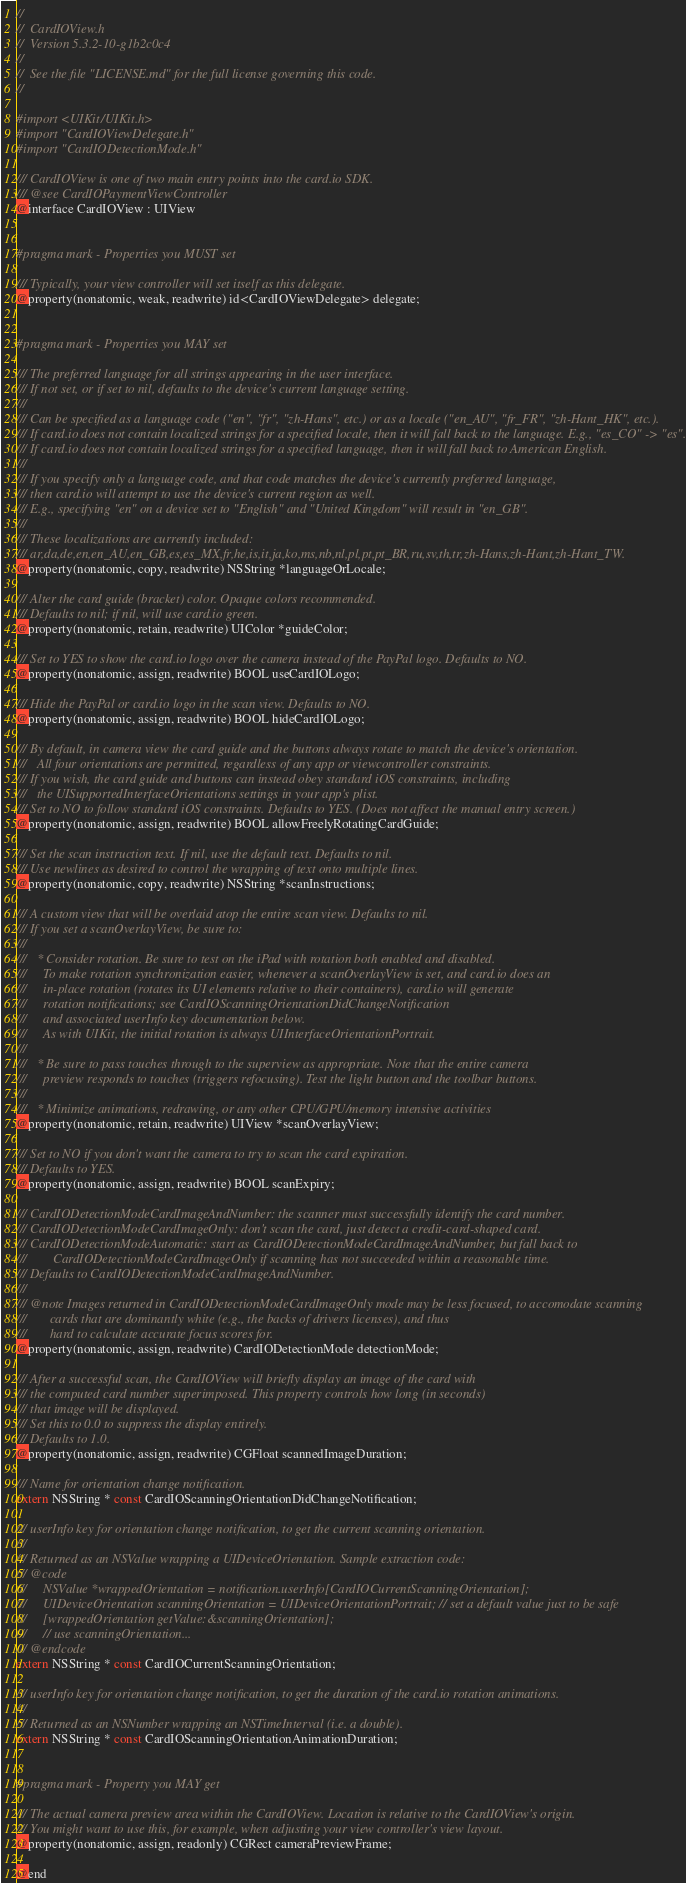<code> <loc_0><loc_0><loc_500><loc_500><_C_>//
//  CardIOView.h
//  Version 5.3.2-10-g1b2c0c4
//
//  See the file "LICENSE.md" for the full license governing this code.
//

#import <UIKit/UIKit.h>
#import "CardIOViewDelegate.h"
#import "CardIODetectionMode.h"

/// CardIOView is one of two main entry points into the card.io SDK.
/// @see CardIOPaymentViewController
@interface CardIOView : UIView


#pragma mark - Properties you MUST set

/// Typically, your view controller will set itself as this delegate.
@property(nonatomic, weak, readwrite) id<CardIOViewDelegate> delegate;


#pragma mark - Properties you MAY set

/// The preferred language for all strings appearing in the user interface.
/// If not set, or if set to nil, defaults to the device's current language setting.
///
/// Can be specified as a language code ("en", "fr", "zh-Hans", etc.) or as a locale ("en_AU", "fr_FR", "zh-Hant_HK", etc.).
/// If card.io does not contain localized strings for a specified locale, then it will fall back to the language. E.g., "es_CO" -> "es".
/// If card.io does not contain localized strings for a specified language, then it will fall back to American English.
///
/// If you specify only a language code, and that code matches the device's currently preferred language,
/// then card.io will attempt to use the device's current region as well.
/// E.g., specifying "en" on a device set to "English" and "United Kingdom" will result in "en_GB".
///
/// These localizations are currently included:
/// ar,da,de,en,en_AU,en_GB,es,es_MX,fr,he,is,it,ja,ko,ms,nb,nl,pl,pt,pt_BR,ru,sv,th,tr,zh-Hans,zh-Hant,zh-Hant_TW.
@property(nonatomic, copy, readwrite) NSString *languageOrLocale;

/// Alter the card guide (bracket) color. Opaque colors recommended.
/// Defaults to nil; if nil, will use card.io green.
@property(nonatomic, retain, readwrite) UIColor *guideColor;

/// Set to YES to show the card.io logo over the camera instead of the PayPal logo. Defaults to NO.
@property(nonatomic, assign, readwrite) BOOL useCardIOLogo;

/// Hide the PayPal or card.io logo in the scan view. Defaults to NO.
@property(nonatomic, assign, readwrite) BOOL hideCardIOLogo;

/// By default, in camera view the card guide and the buttons always rotate to match the device's orientation.
///   All four orientations are permitted, regardless of any app or viewcontroller constraints.
/// If you wish, the card guide and buttons can instead obey standard iOS constraints, including
///   the UISupportedInterfaceOrientations settings in your app's plist.
/// Set to NO to follow standard iOS constraints. Defaults to YES. (Does not affect the manual entry screen.)
@property(nonatomic, assign, readwrite) BOOL allowFreelyRotatingCardGuide;

/// Set the scan instruction text. If nil, use the default text. Defaults to nil.
/// Use newlines as desired to control the wrapping of text onto multiple lines.
@property(nonatomic, copy, readwrite) NSString *scanInstructions;

/// A custom view that will be overlaid atop the entire scan view. Defaults to nil.
/// If you set a scanOverlayView, be sure to:
///
///   * Consider rotation. Be sure to test on the iPad with rotation both enabled and disabled.
///     To make rotation synchronization easier, whenever a scanOverlayView is set, and card.io does an
///     in-place rotation (rotates its UI elements relative to their containers), card.io will generate
///     rotation notifications; see CardIOScanningOrientationDidChangeNotification
///     and associated userInfo key documentation below.
///     As with UIKit, the initial rotation is always UIInterfaceOrientationPortrait.
///
///   * Be sure to pass touches through to the superview as appropriate. Note that the entire camera
///     preview responds to touches (triggers refocusing). Test the light button and the toolbar buttons.
///
///   * Minimize animations, redrawing, or any other CPU/GPU/memory intensive activities
@property(nonatomic, retain, readwrite) UIView *scanOverlayView;

/// Set to NO if you don't want the camera to try to scan the card expiration.
/// Defaults to YES.
@property(nonatomic, assign, readwrite) BOOL scanExpiry;

/// CardIODetectionModeCardImageAndNumber: the scanner must successfully identify the card number.
/// CardIODetectionModeCardImageOnly: don't scan the card, just detect a credit-card-shaped card.
/// CardIODetectionModeAutomatic: start as CardIODetectionModeCardImageAndNumber, but fall back to
///        CardIODetectionModeCardImageOnly if scanning has not succeeded within a reasonable time.
/// Defaults to CardIODetectionModeCardImageAndNumber.
///
/// @note Images returned in CardIODetectionModeCardImageOnly mode may be less focused, to accomodate scanning
///       cards that are dominantly white (e.g., the backs of drivers licenses), and thus
///       hard to calculate accurate focus scores for.
@property(nonatomic, assign, readwrite) CardIODetectionMode detectionMode;

/// After a successful scan, the CardIOView will briefly display an image of the card with
/// the computed card number superimposed. This property controls how long (in seconds)
/// that image will be displayed.
/// Set this to 0.0 to suppress the display entirely.
/// Defaults to 1.0.
@property(nonatomic, assign, readwrite) CGFloat scannedImageDuration;

/// Name for orientation change notification.
extern NSString * const CardIOScanningOrientationDidChangeNotification;

/// userInfo key for orientation change notification, to get the current scanning orientation.
///
/// Returned as an NSValue wrapping a UIDeviceOrientation. Sample extraction code:
/// @code
///     NSValue *wrappedOrientation = notification.userInfo[CardIOCurrentScanningOrientation];
///     UIDeviceOrientation scanningOrientation = UIDeviceOrientationPortrait; // set a default value just to be safe
///     [wrappedOrientation getValue:&scanningOrientation];
///     // use scanningOrientation...
/// @endcode
extern NSString * const CardIOCurrentScanningOrientation;

/// userInfo key for orientation change notification, to get the duration of the card.io rotation animations.
///
/// Returned as an NSNumber wrapping an NSTimeInterval (i.e. a double).
extern NSString * const CardIOScanningOrientationAnimationDuration;


#pragma mark - Property you MAY get

/// The actual camera preview area within the CardIOView. Location is relative to the CardIOView's origin.
/// You might want to use this, for example, when adjusting your view controller's view layout.
@property(nonatomic, assign, readonly) CGRect cameraPreviewFrame;

@end
</code> 